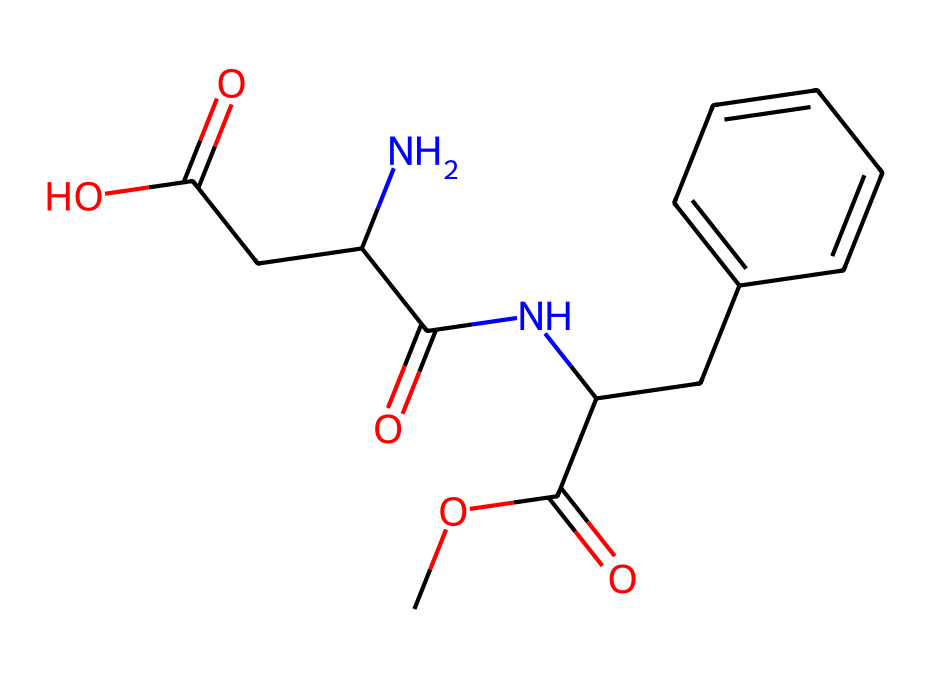What is the molecular formula of aspartame? To find the molecular formula, count the number of each type of atom represented in the SMILES. By analyzing the structure, we have 14 carbons (C), 18 hydrogens (H), 2 nitrogens (N), and 2 oxygens (O). Thus, the molecular formula is C14H18N2O5.
Answer: C14H18N2O5 How many rings are present in aspartame's structure? By examining the chemical structure represented by the SMILES, we can observe that there are no circular bonds indicating ring structures. All segments are open chains.
Answer: 0 What functional groups are present in aspartame? Investigating the functional groups within the SMILES, we can identify an amide group (due to nitrogen and carbonyl), ester (from the -COOC- segment), and a carboxylic acid group (-COOH).
Answer: amide, ester, carboxylic acid How many chiral centers are in aspartame? Chiral centers exist where a carbon atom is bonded to four different substituents. In the provided structure, there are two carbon atoms fitting this criterion.
Answer: 2 Which part of the aspartame structure contributes to its sweetness? The sweet taste of aspartame is associated with the specific arrangement of the carbon and nitrogen atoms in the amide portion of the molecule. The unique stereochemistry here is key to its sensory properties.
Answer: amide portion What is the significance of the nitrogen atoms in aspartame? The nitrogen atoms are crucial as they are part of the amide functional group, impacting both the biochemical behavior of aspartame and its interaction with taste receptors, contributing to its sweet flavor profile.
Answer: amide functional group 